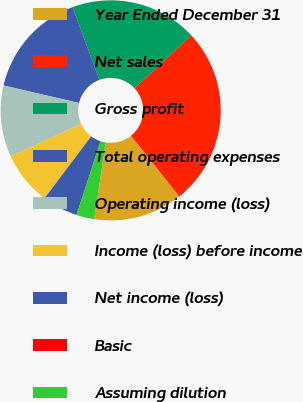<chart> <loc_0><loc_0><loc_500><loc_500><pie_chart><fcel>Year Ended December 31<fcel>Net sales<fcel>Gross profit<fcel>Total operating expenses<fcel>Operating income (loss)<fcel>Income (loss) before income<fcel>Net income (loss)<fcel>Basic<fcel>Assuming dilution<nl><fcel>13.11%<fcel>26.22%<fcel>18.71%<fcel>15.73%<fcel>10.49%<fcel>7.87%<fcel>5.24%<fcel>0.0%<fcel>2.62%<nl></chart> 